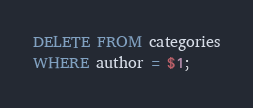<code> <loc_0><loc_0><loc_500><loc_500><_SQL_>DELETE FROM categories
WHERE author = $1;

</code> 